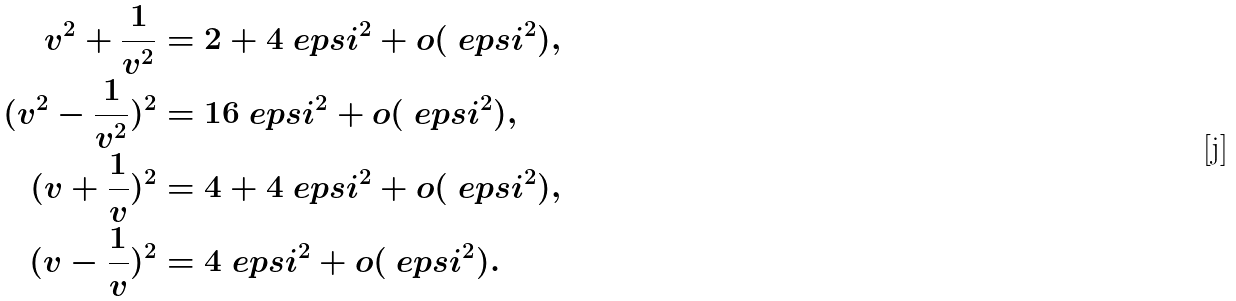Convert formula to latex. <formula><loc_0><loc_0><loc_500><loc_500>v ^ { 2 } + \frac { 1 } { v ^ { 2 } } & = 2 + 4 \ e p s i ^ { 2 } + o ( \ e p s i ^ { 2 } ) , \\ ( v ^ { 2 } - \frac { 1 } { v ^ { 2 } } ) ^ { 2 } & = 1 6 \ e p s i ^ { 2 } + o ( \ e p s i ^ { 2 } ) , \\ ( v + \frac { 1 } { v } ) ^ { 2 } & = 4 + 4 \ e p s i ^ { 2 } + o ( \ e p s i ^ { 2 } ) , \\ ( v - \frac { 1 } { v } ) ^ { 2 } & = 4 \ e p s i ^ { 2 } + o ( \ e p s i ^ { 2 } ) .</formula> 